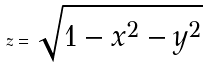Convert formula to latex. <formula><loc_0><loc_0><loc_500><loc_500>z = \sqrt { 1 - x ^ { 2 } - y ^ { 2 } }</formula> 